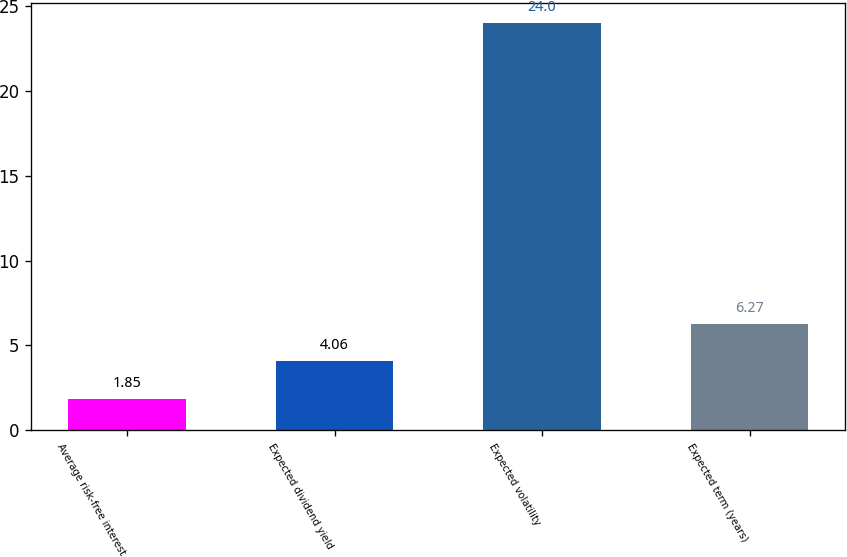Convert chart to OTSL. <chart><loc_0><loc_0><loc_500><loc_500><bar_chart><fcel>Average risk-free interest<fcel>Expected dividend yield<fcel>Expected volatility<fcel>Expected term (years)<nl><fcel>1.85<fcel>4.06<fcel>24<fcel>6.27<nl></chart> 